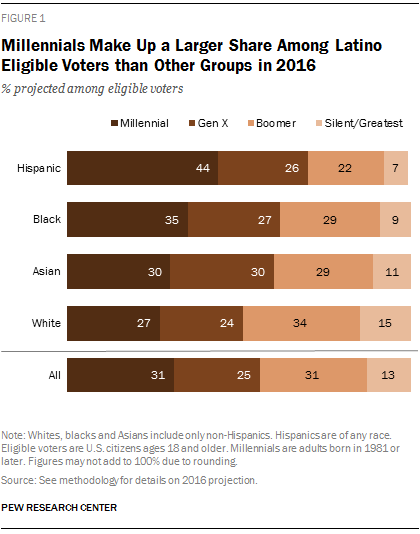Indicate a few pertinent items in this graphic. According to a recent study, a significant percentage of baby boomers are found within the Hispanic population, with a specific number being 26%. In at least three racial groups, more than 25% of the population are baby boomers. 